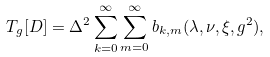Convert formula to latex. <formula><loc_0><loc_0><loc_500><loc_500>T _ { g } [ D ] = \Delta ^ { 2 } \sum _ { k = 0 } ^ { \infty } \sum _ { m = 0 } ^ { \infty } b _ { k , m } ( \lambda , \nu , \xi , g ^ { 2 } ) ,</formula> 